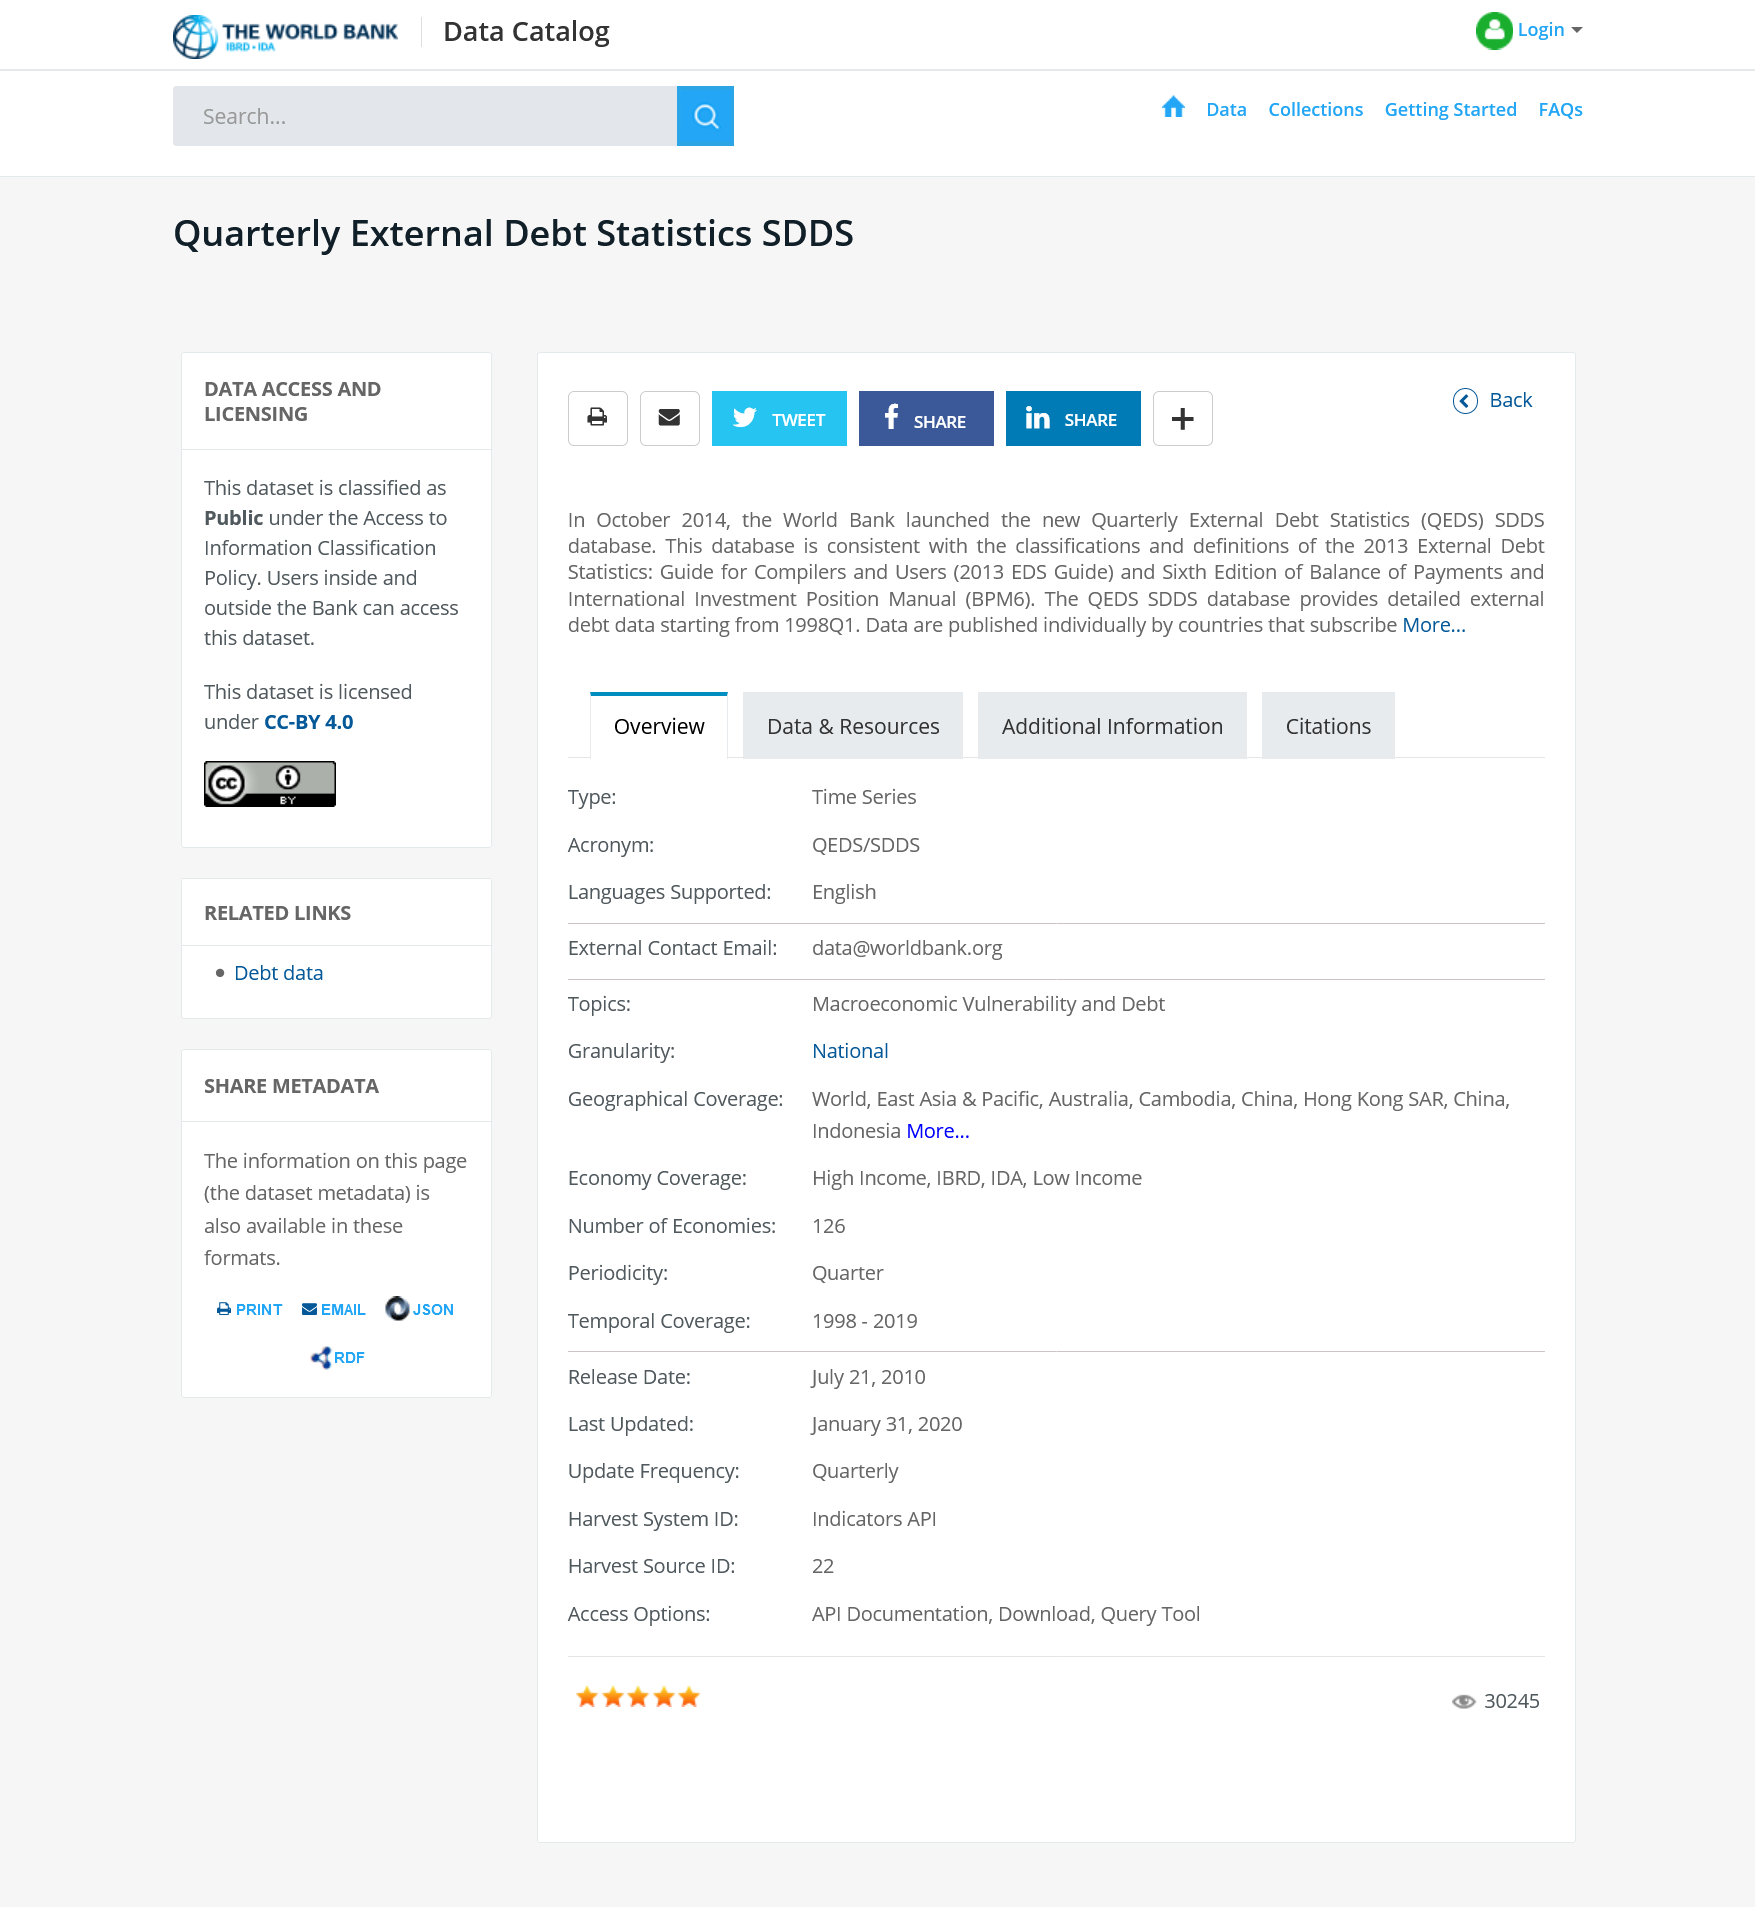Highlight a few significant elements in this photo. This dataset is accessible to both bank employees and external users. The World Bank launched the new QEDS SSDS database in October 2014. The acronym "QEDS" stands for "Quarterly External Debt Statistics. 